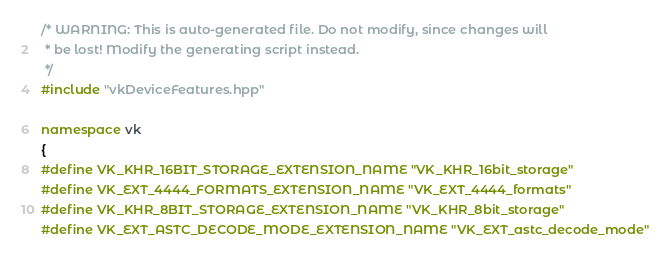<code> <loc_0><loc_0><loc_500><loc_500><_C++_>/* WARNING: This is auto-generated file. Do not modify, since changes will
 * be lost! Modify the generating script instead.
 */
#include "vkDeviceFeatures.hpp"

namespace vk
{
#define VK_KHR_16BIT_STORAGE_EXTENSION_NAME "VK_KHR_16bit_storage"
#define VK_EXT_4444_FORMATS_EXTENSION_NAME "VK_EXT_4444_formats"
#define VK_KHR_8BIT_STORAGE_EXTENSION_NAME "VK_KHR_8bit_storage"
#define VK_EXT_ASTC_DECODE_MODE_EXTENSION_NAME "VK_EXT_astc_decode_mode"</code> 